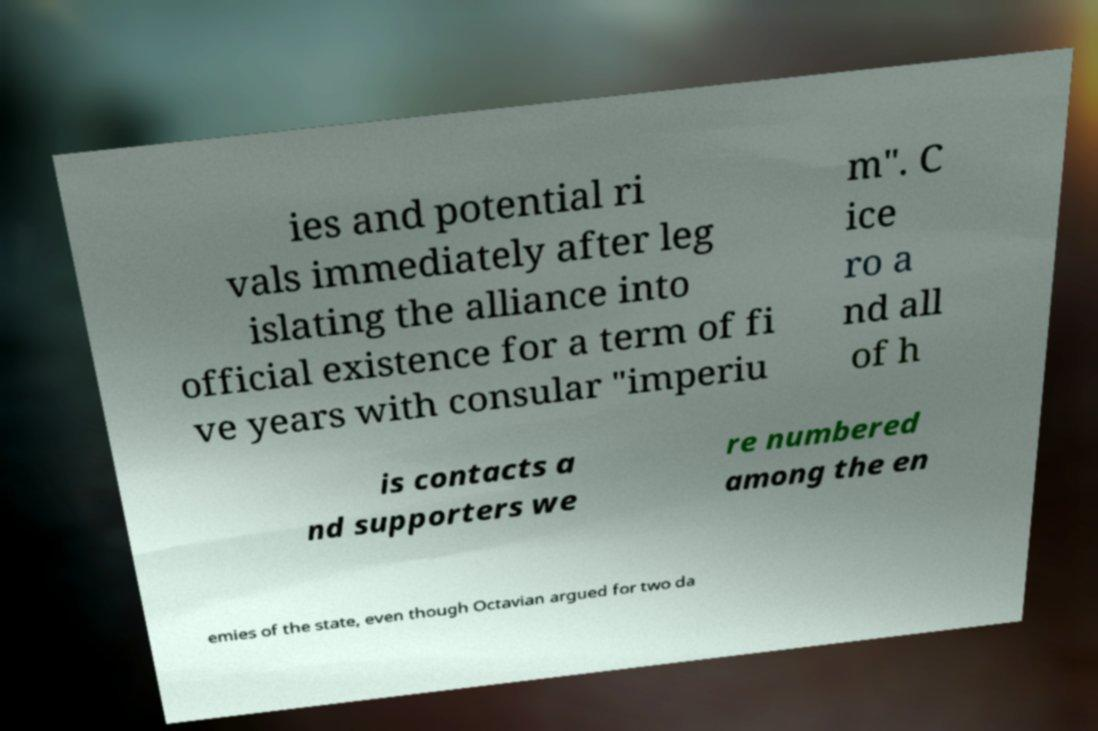Please read and relay the text visible in this image. What does it say? ies and potential ri vals immediately after leg islating the alliance into official existence for a term of fi ve years with consular "imperiu m". C ice ro a nd all of h is contacts a nd supporters we re numbered among the en emies of the state, even though Octavian argued for two da 